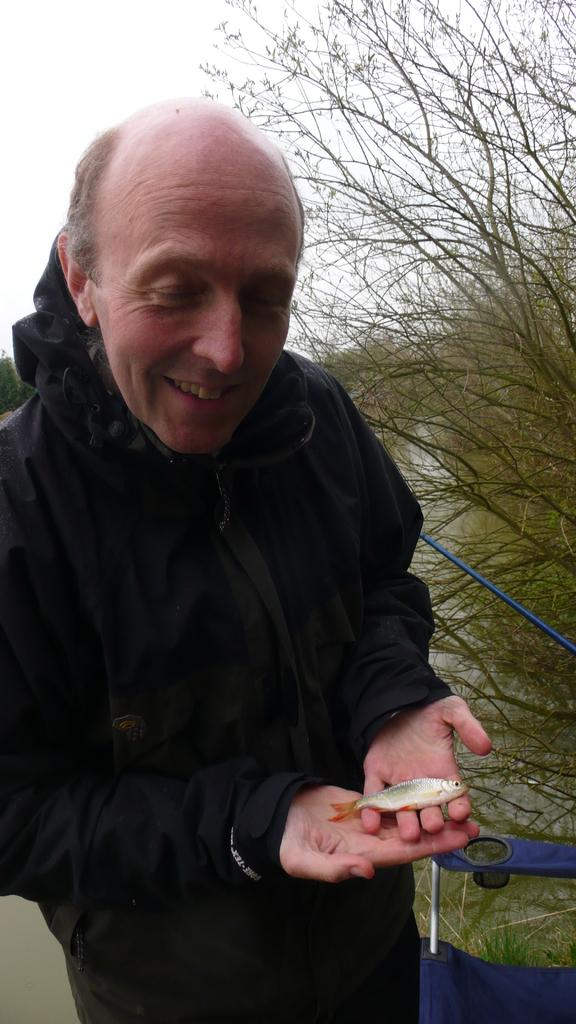What is the main subject of the image? There is a person in the image. What is the person wearing? The person is wearing a black dress. What is the person holding in their hand? The person is holding a fish in their hand. What color is the object beside the person? There is a blue color object beside the person. What can be seen in the background of the image? There are trees in the background of the image. What type of truck can be seen flying in the background of the image? There is no truck or flight present in the image; it features a person holding a fish and trees in the background. 